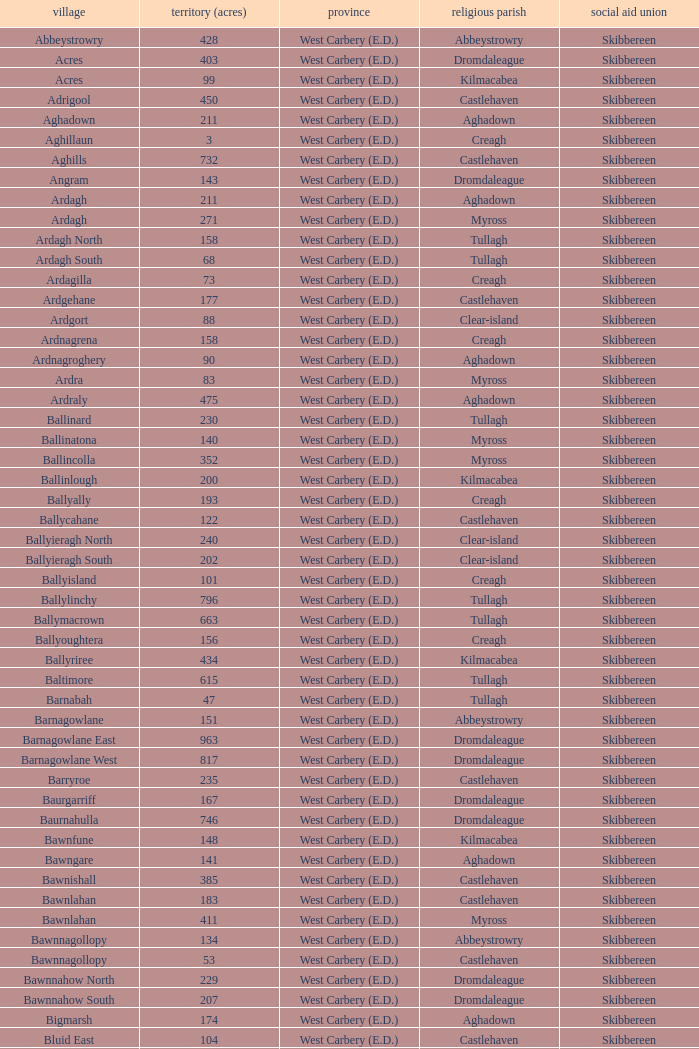What are the areas (in acres) of the Kilnahera East townland? 257.0. 